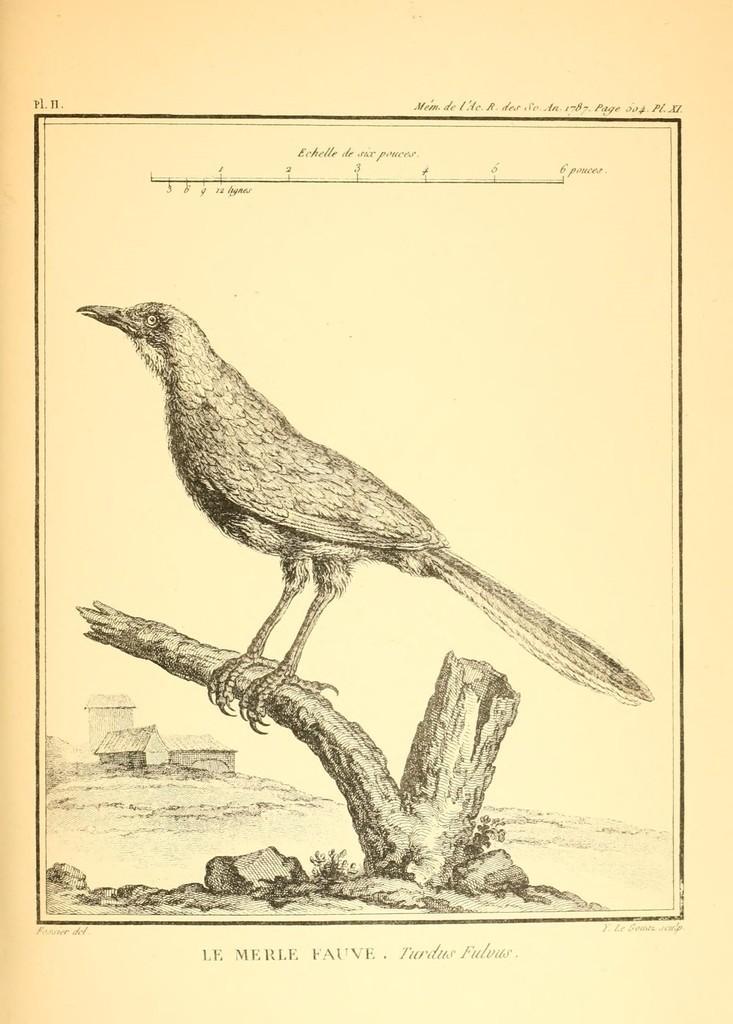Could you give a brief overview of what you see in this image? In this picture we can see the drawing of a bird on the paper and the bird is standing on the branch. Behind the bird there are houses. On the paper it is written something. 